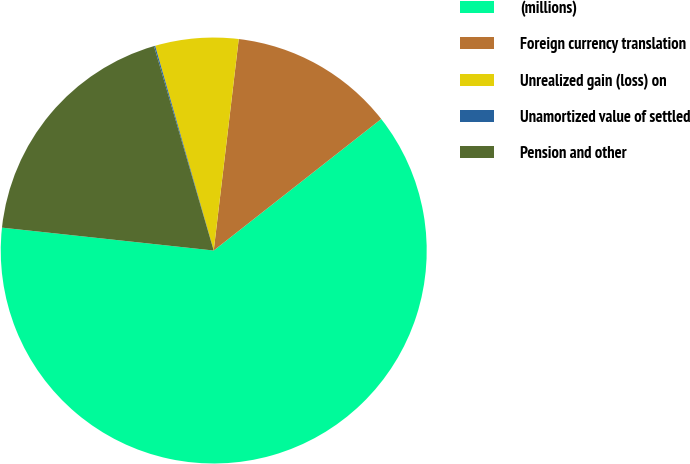Convert chart to OTSL. <chart><loc_0><loc_0><loc_500><loc_500><pie_chart><fcel>(millions)<fcel>Foreign currency translation<fcel>Unrealized gain (loss) on<fcel>Unamortized value of settled<fcel>Pension and other<nl><fcel>62.31%<fcel>12.53%<fcel>6.31%<fcel>0.09%<fcel>18.76%<nl></chart> 